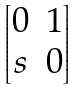<formula> <loc_0><loc_0><loc_500><loc_500>\begin{bmatrix} 0 & 1 \\ s & 0 \end{bmatrix}</formula> 